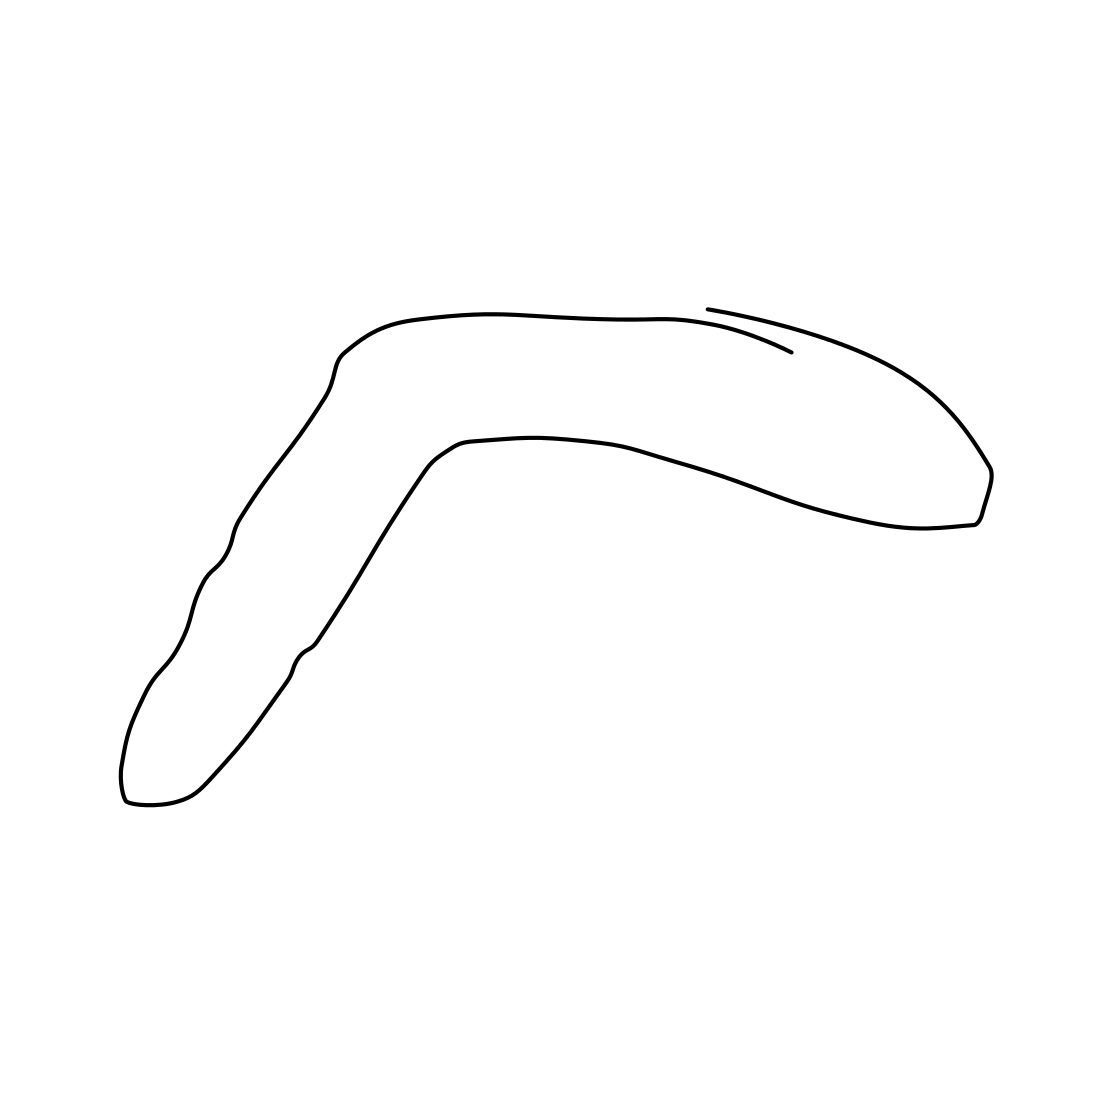Can you describe what is depicted in this image? This image features a minimalistic line drawing of a shape resembling a boomerang. It has a smooth, curved form and a very streamlined, abstract appearance. 